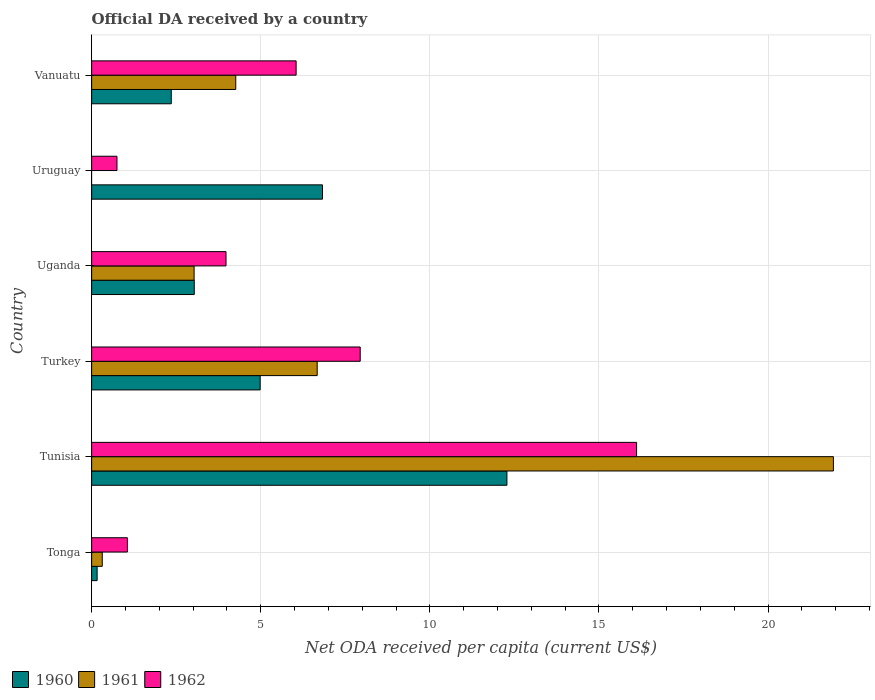How many groups of bars are there?
Offer a very short reply. 6. Are the number of bars per tick equal to the number of legend labels?
Your answer should be very brief. No. Are the number of bars on each tick of the Y-axis equal?
Provide a short and direct response. No. What is the label of the 3rd group of bars from the top?
Offer a terse response. Uganda. What is the ODA received in in 1961 in Uganda?
Offer a terse response. 3.03. Across all countries, what is the maximum ODA received in in 1960?
Offer a terse response. 12.28. Across all countries, what is the minimum ODA received in in 1962?
Provide a short and direct response. 0.75. In which country was the ODA received in in 1962 maximum?
Your answer should be compact. Tunisia. What is the total ODA received in in 1961 in the graph?
Your answer should be very brief. 36.21. What is the difference between the ODA received in in 1962 in Tunisia and that in Uruguay?
Your answer should be compact. 15.37. What is the difference between the ODA received in in 1962 in Tonga and the ODA received in in 1961 in Turkey?
Your answer should be compact. -5.61. What is the average ODA received in in 1961 per country?
Offer a very short reply. 6.03. What is the difference between the ODA received in in 1960 and ODA received in in 1961 in Tunisia?
Your answer should be compact. -9.65. In how many countries, is the ODA received in in 1960 greater than 7 US$?
Make the answer very short. 1. What is the ratio of the ODA received in in 1962 in Uganda to that in Uruguay?
Your answer should be compact. 5.31. What is the difference between the highest and the second highest ODA received in in 1961?
Provide a succinct answer. 15.26. What is the difference between the highest and the lowest ODA received in in 1962?
Provide a short and direct response. 15.37. In how many countries, is the ODA received in in 1960 greater than the average ODA received in in 1960 taken over all countries?
Ensure brevity in your answer.  3. Is the sum of the ODA received in in 1962 in Turkey and Vanuatu greater than the maximum ODA received in in 1960 across all countries?
Make the answer very short. Yes. Is it the case that in every country, the sum of the ODA received in in 1962 and ODA received in in 1960 is greater than the ODA received in in 1961?
Give a very brief answer. Yes. How many bars are there?
Ensure brevity in your answer.  17. Are all the bars in the graph horizontal?
Ensure brevity in your answer.  Yes. What is the difference between two consecutive major ticks on the X-axis?
Your response must be concise. 5. Are the values on the major ticks of X-axis written in scientific E-notation?
Provide a succinct answer. No. Does the graph contain any zero values?
Offer a terse response. Yes. What is the title of the graph?
Make the answer very short. Official DA received by a country. Does "1969" appear as one of the legend labels in the graph?
Keep it short and to the point. No. What is the label or title of the X-axis?
Make the answer very short. Net ODA received per capita (current US$). What is the Net ODA received per capita (current US$) in 1960 in Tonga?
Give a very brief answer. 0.16. What is the Net ODA received per capita (current US$) of 1961 in Tonga?
Offer a very short reply. 0.31. What is the Net ODA received per capita (current US$) of 1962 in Tonga?
Offer a very short reply. 1.06. What is the Net ODA received per capita (current US$) in 1960 in Tunisia?
Keep it short and to the point. 12.28. What is the Net ODA received per capita (current US$) in 1961 in Tunisia?
Give a very brief answer. 21.93. What is the Net ODA received per capita (current US$) in 1962 in Tunisia?
Offer a very short reply. 16.11. What is the Net ODA received per capita (current US$) of 1960 in Turkey?
Provide a short and direct response. 4.98. What is the Net ODA received per capita (current US$) in 1961 in Turkey?
Your response must be concise. 6.67. What is the Net ODA received per capita (current US$) in 1962 in Turkey?
Keep it short and to the point. 7.94. What is the Net ODA received per capita (current US$) of 1960 in Uganda?
Ensure brevity in your answer.  3.03. What is the Net ODA received per capita (current US$) of 1961 in Uganda?
Provide a succinct answer. 3.03. What is the Net ODA received per capita (current US$) of 1962 in Uganda?
Your answer should be compact. 3.97. What is the Net ODA received per capita (current US$) in 1960 in Uruguay?
Provide a succinct answer. 6.83. What is the Net ODA received per capita (current US$) of 1961 in Uruguay?
Give a very brief answer. 0. What is the Net ODA received per capita (current US$) in 1962 in Uruguay?
Make the answer very short. 0.75. What is the Net ODA received per capita (current US$) in 1960 in Vanuatu?
Offer a terse response. 2.35. What is the Net ODA received per capita (current US$) in 1961 in Vanuatu?
Provide a succinct answer. 4.26. What is the Net ODA received per capita (current US$) in 1962 in Vanuatu?
Your answer should be very brief. 6.05. Across all countries, what is the maximum Net ODA received per capita (current US$) in 1960?
Ensure brevity in your answer.  12.28. Across all countries, what is the maximum Net ODA received per capita (current US$) in 1961?
Offer a terse response. 21.93. Across all countries, what is the maximum Net ODA received per capita (current US$) of 1962?
Make the answer very short. 16.11. Across all countries, what is the minimum Net ODA received per capita (current US$) of 1960?
Your answer should be very brief. 0.16. Across all countries, what is the minimum Net ODA received per capita (current US$) of 1961?
Make the answer very short. 0. Across all countries, what is the minimum Net ODA received per capita (current US$) in 1962?
Your response must be concise. 0.75. What is the total Net ODA received per capita (current US$) in 1960 in the graph?
Make the answer very short. 29.64. What is the total Net ODA received per capita (current US$) in 1961 in the graph?
Your response must be concise. 36.21. What is the total Net ODA received per capita (current US$) in 1962 in the graph?
Give a very brief answer. 35.88. What is the difference between the Net ODA received per capita (current US$) of 1960 in Tonga and that in Tunisia?
Your answer should be compact. -12.12. What is the difference between the Net ODA received per capita (current US$) in 1961 in Tonga and that in Tunisia?
Your response must be concise. -21.62. What is the difference between the Net ODA received per capita (current US$) of 1962 in Tonga and that in Tunisia?
Your answer should be very brief. -15.06. What is the difference between the Net ODA received per capita (current US$) of 1960 in Tonga and that in Turkey?
Keep it short and to the point. -4.82. What is the difference between the Net ODA received per capita (current US$) of 1961 in Tonga and that in Turkey?
Make the answer very short. -6.36. What is the difference between the Net ODA received per capita (current US$) of 1962 in Tonga and that in Turkey?
Your answer should be very brief. -6.88. What is the difference between the Net ODA received per capita (current US$) of 1960 in Tonga and that in Uganda?
Offer a very short reply. -2.87. What is the difference between the Net ODA received per capita (current US$) of 1961 in Tonga and that in Uganda?
Ensure brevity in your answer.  -2.72. What is the difference between the Net ODA received per capita (current US$) in 1962 in Tonga and that in Uganda?
Your answer should be compact. -2.92. What is the difference between the Net ODA received per capita (current US$) of 1960 in Tonga and that in Uruguay?
Offer a terse response. -6.66. What is the difference between the Net ODA received per capita (current US$) of 1962 in Tonga and that in Uruguay?
Your answer should be very brief. 0.31. What is the difference between the Net ODA received per capita (current US$) of 1960 in Tonga and that in Vanuatu?
Your answer should be compact. -2.19. What is the difference between the Net ODA received per capita (current US$) in 1961 in Tonga and that in Vanuatu?
Make the answer very short. -3.95. What is the difference between the Net ODA received per capita (current US$) in 1962 in Tonga and that in Vanuatu?
Provide a short and direct response. -4.99. What is the difference between the Net ODA received per capita (current US$) of 1960 in Tunisia and that in Turkey?
Your response must be concise. 7.3. What is the difference between the Net ODA received per capita (current US$) in 1961 in Tunisia and that in Turkey?
Your answer should be compact. 15.26. What is the difference between the Net ODA received per capita (current US$) of 1962 in Tunisia and that in Turkey?
Provide a short and direct response. 8.17. What is the difference between the Net ODA received per capita (current US$) of 1960 in Tunisia and that in Uganda?
Your answer should be compact. 9.25. What is the difference between the Net ODA received per capita (current US$) of 1961 in Tunisia and that in Uganda?
Give a very brief answer. 18.9. What is the difference between the Net ODA received per capita (current US$) of 1962 in Tunisia and that in Uganda?
Give a very brief answer. 12.14. What is the difference between the Net ODA received per capita (current US$) of 1960 in Tunisia and that in Uruguay?
Offer a terse response. 5.45. What is the difference between the Net ODA received per capita (current US$) in 1962 in Tunisia and that in Uruguay?
Give a very brief answer. 15.37. What is the difference between the Net ODA received per capita (current US$) of 1960 in Tunisia and that in Vanuatu?
Provide a succinct answer. 9.93. What is the difference between the Net ODA received per capita (current US$) in 1961 in Tunisia and that in Vanuatu?
Keep it short and to the point. 17.67. What is the difference between the Net ODA received per capita (current US$) in 1962 in Tunisia and that in Vanuatu?
Your answer should be compact. 10.07. What is the difference between the Net ODA received per capita (current US$) of 1960 in Turkey and that in Uganda?
Keep it short and to the point. 1.95. What is the difference between the Net ODA received per capita (current US$) in 1961 in Turkey and that in Uganda?
Keep it short and to the point. 3.64. What is the difference between the Net ODA received per capita (current US$) in 1962 in Turkey and that in Uganda?
Your response must be concise. 3.97. What is the difference between the Net ODA received per capita (current US$) of 1960 in Turkey and that in Uruguay?
Keep it short and to the point. -1.84. What is the difference between the Net ODA received per capita (current US$) in 1962 in Turkey and that in Uruguay?
Offer a terse response. 7.19. What is the difference between the Net ODA received per capita (current US$) of 1960 in Turkey and that in Vanuatu?
Make the answer very short. 2.63. What is the difference between the Net ODA received per capita (current US$) in 1961 in Turkey and that in Vanuatu?
Ensure brevity in your answer.  2.41. What is the difference between the Net ODA received per capita (current US$) in 1962 in Turkey and that in Vanuatu?
Ensure brevity in your answer.  1.89. What is the difference between the Net ODA received per capita (current US$) in 1960 in Uganda and that in Uruguay?
Offer a terse response. -3.79. What is the difference between the Net ODA received per capita (current US$) in 1962 in Uganda and that in Uruguay?
Ensure brevity in your answer.  3.22. What is the difference between the Net ODA received per capita (current US$) of 1960 in Uganda and that in Vanuatu?
Give a very brief answer. 0.68. What is the difference between the Net ODA received per capita (current US$) of 1961 in Uganda and that in Vanuatu?
Your answer should be compact. -1.23. What is the difference between the Net ODA received per capita (current US$) of 1962 in Uganda and that in Vanuatu?
Provide a short and direct response. -2.07. What is the difference between the Net ODA received per capita (current US$) in 1960 in Uruguay and that in Vanuatu?
Keep it short and to the point. 4.47. What is the difference between the Net ODA received per capita (current US$) in 1962 in Uruguay and that in Vanuatu?
Your answer should be compact. -5.3. What is the difference between the Net ODA received per capita (current US$) in 1960 in Tonga and the Net ODA received per capita (current US$) in 1961 in Tunisia?
Offer a very short reply. -21.77. What is the difference between the Net ODA received per capita (current US$) of 1960 in Tonga and the Net ODA received per capita (current US$) of 1962 in Tunisia?
Keep it short and to the point. -15.95. What is the difference between the Net ODA received per capita (current US$) of 1961 in Tonga and the Net ODA received per capita (current US$) of 1962 in Tunisia?
Your answer should be very brief. -15.8. What is the difference between the Net ODA received per capita (current US$) in 1960 in Tonga and the Net ODA received per capita (current US$) in 1961 in Turkey?
Make the answer very short. -6.51. What is the difference between the Net ODA received per capita (current US$) of 1960 in Tonga and the Net ODA received per capita (current US$) of 1962 in Turkey?
Offer a very short reply. -7.78. What is the difference between the Net ODA received per capita (current US$) in 1961 in Tonga and the Net ODA received per capita (current US$) in 1962 in Turkey?
Provide a short and direct response. -7.63. What is the difference between the Net ODA received per capita (current US$) in 1960 in Tonga and the Net ODA received per capita (current US$) in 1961 in Uganda?
Make the answer very short. -2.87. What is the difference between the Net ODA received per capita (current US$) in 1960 in Tonga and the Net ODA received per capita (current US$) in 1962 in Uganda?
Your response must be concise. -3.81. What is the difference between the Net ODA received per capita (current US$) of 1961 in Tonga and the Net ODA received per capita (current US$) of 1962 in Uganda?
Keep it short and to the point. -3.66. What is the difference between the Net ODA received per capita (current US$) of 1960 in Tonga and the Net ODA received per capita (current US$) of 1962 in Uruguay?
Keep it short and to the point. -0.59. What is the difference between the Net ODA received per capita (current US$) of 1961 in Tonga and the Net ODA received per capita (current US$) of 1962 in Uruguay?
Make the answer very short. -0.44. What is the difference between the Net ODA received per capita (current US$) in 1960 in Tonga and the Net ODA received per capita (current US$) in 1961 in Vanuatu?
Your response must be concise. -4.1. What is the difference between the Net ODA received per capita (current US$) of 1960 in Tonga and the Net ODA received per capita (current US$) of 1962 in Vanuatu?
Offer a very short reply. -5.88. What is the difference between the Net ODA received per capita (current US$) of 1961 in Tonga and the Net ODA received per capita (current US$) of 1962 in Vanuatu?
Your answer should be very brief. -5.73. What is the difference between the Net ODA received per capita (current US$) in 1960 in Tunisia and the Net ODA received per capita (current US$) in 1961 in Turkey?
Give a very brief answer. 5.61. What is the difference between the Net ODA received per capita (current US$) of 1960 in Tunisia and the Net ODA received per capita (current US$) of 1962 in Turkey?
Give a very brief answer. 4.34. What is the difference between the Net ODA received per capita (current US$) in 1961 in Tunisia and the Net ODA received per capita (current US$) in 1962 in Turkey?
Make the answer very short. 13.99. What is the difference between the Net ODA received per capita (current US$) of 1960 in Tunisia and the Net ODA received per capita (current US$) of 1961 in Uganda?
Ensure brevity in your answer.  9.25. What is the difference between the Net ODA received per capita (current US$) of 1960 in Tunisia and the Net ODA received per capita (current US$) of 1962 in Uganda?
Ensure brevity in your answer.  8.31. What is the difference between the Net ODA received per capita (current US$) of 1961 in Tunisia and the Net ODA received per capita (current US$) of 1962 in Uganda?
Give a very brief answer. 17.96. What is the difference between the Net ODA received per capita (current US$) in 1960 in Tunisia and the Net ODA received per capita (current US$) in 1962 in Uruguay?
Give a very brief answer. 11.53. What is the difference between the Net ODA received per capita (current US$) in 1961 in Tunisia and the Net ODA received per capita (current US$) in 1962 in Uruguay?
Provide a short and direct response. 21.19. What is the difference between the Net ODA received per capita (current US$) in 1960 in Tunisia and the Net ODA received per capita (current US$) in 1961 in Vanuatu?
Offer a terse response. 8.02. What is the difference between the Net ODA received per capita (current US$) in 1960 in Tunisia and the Net ODA received per capita (current US$) in 1962 in Vanuatu?
Offer a very short reply. 6.23. What is the difference between the Net ODA received per capita (current US$) of 1961 in Tunisia and the Net ODA received per capita (current US$) of 1962 in Vanuatu?
Keep it short and to the point. 15.89. What is the difference between the Net ODA received per capita (current US$) in 1960 in Turkey and the Net ODA received per capita (current US$) in 1961 in Uganda?
Provide a short and direct response. 1.95. What is the difference between the Net ODA received per capita (current US$) in 1960 in Turkey and the Net ODA received per capita (current US$) in 1962 in Uganda?
Your answer should be very brief. 1.01. What is the difference between the Net ODA received per capita (current US$) in 1961 in Turkey and the Net ODA received per capita (current US$) in 1962 in Uganda?
Give a very brief answer. 2.7. What is the difference between the Net ODA received per capita (current US$) of 1960 in Turkey and the Net ODA received per capita (current US$) of 1962 in Uruguay?
Keep it short and to the point. 4.23. What is the difference between the Net ODA received per capita (current US$) of 1961 in Turkey and the Net ODA received per capita (current US$) of 1962 in Uruguay?
Offer a very short reply. 5.92. What is the difference between the Net ODA received per capita (current US$) of 1960 in Turkey and the Net ODA received per capita (current US$) of 1961 in Vanuatu?
Offer a very short reply. 0.72. What is the difference between the Net ODA received per capita (current US$) of 1960 in Turkey and the Net ODA received per capita (current US$) of 1962 in Vanuatu?
Your answer should be very brief. -1.06. What is the difference between the Net ODA received per capita (current US$) of 1961 in Turkey and the Net ODA received per capita (current US$) of 1962 in Vanuatu?
Ensure brevity in your answer.  0.62. What is the difference between the Net ODA received per capita (current US$) of 1960 in Uganda and the Net ODA received per capita (current US$) of 1962 in Uruguay?
Provide a short and direct response. 2.29. What is the difference between the Net ODA received per capita (current US$) of 1961 in Uganda and the Net ODA received per capita (current US$) of 1962 in Uruguay?
Give a very brief answer. 2.28. What is the difference between the Net ODA received per capita (current US$) of 1960 in Uganda and the Net ODA received per capita (current US$) of 1961 in Vanuatu?
Keep it short and to the point. -1.23. What is the difference between the Net ODA received per capita (current US$) in 1960 in Uganda and the Net ODA received per capita (current US$) in 1962 in Vanuatu?
Offer a very short reply. -3.01. What is the difference between the Net ODA received per capita (current US$) of 1961 in Uganda and the Net ODA received per capita (current US$) of 1962 in Vanuatu?
Make the answer very short. -3.02. What is the difference between the Net ODA received per capita (current US$) of 1960 in Uruguay and the Net ODA received per capita (current US$) of 1961 in Vanuatu?
Ensure brevity in your answer.  2.57. What is the difference between the Net ODA received per capita (current US$) of 1960 in Uruguay and the Net ODA received per capita (current US$) of 1962 in Vanuatu?
Your answer should be very brief. 0.78. What is the average Net ODA received per capita (current US$) in 1960 per country?
Offer a terse response. 4.94. What is the average Net ODA received per capita (current US$) of 1961 per country?
Offer a very short reply. 6.03. What is the average Net ODA received per capita (current US$) of 1962 per country?
Provide a succinct answer. 5.98. What is the difference between the Net ODA received per capita (current US$) in 1960 and Net ODA received per capita (current US$) in 1961 in Tonga?
Give a very brief answer. -0.15. What is the difference between the Net ODA received per capita (current US$) of 1960 and Net ODA received per capita (current US$) of 1962 in Tonga?
Ensure brevity in your answer.  -0.89. What is the difference between the Net ODA received per capita (current US$) of 1961 and Net ODA received per capita (current US$) of 1962 in Tonga?
Ensure brevity in your answer.  -0.74. What is the difference between the Net ODA received per capita (current US$) of 1960 and Net ODA received per capita (current US$) of 1961 in Tunisia?
Ensure brevity in your answer.  -9.65. What is the difference between the Net ODA received per capita (current US$) of 1960 and Net ODA received per capita (current US$) of 1962 in Tunisia?
Your answer should be compact. -3.83. What is the difference between the Net ODA received per capita (current US$) in 1961 and Net ODA received per capita (current US$) in 1962 in Tunisia?
Make the answer very short. 5.82. What is the difference between the Net ODA received per capita (current US$) in 1960 and Net ODA received per capita (current US$) in 1961 in Turkey?
Your answer should be very brief. -1.69. What is the difference between the Net ODA received per capita (current US$) of 1960 and Net ODA received per capita (current US$) of 1962 in Turkey?
Offer a very short reply. -2.96. What is the difference between the Net ODA received per capita (current US$) of 1961 and Net ODA received per capita (current US$) of 1962 in Turkey?
Give a very brief answer. -1.27. What is the difference between the Net ODA received per capita (current US$) in 1960 and Net ODA received per capita (current US$) in 1961 in Uganda?
Offer a very short reply. 0. What is the difference between the Net ODA received per capita (current US$) in 1960 and Net ODA received per capita (current US$) in 1962 in Uganda?
Ensure brevity in your answer.  -0.94. What is the difference between the Net ODA received per capita (current US$) in 1961 and Net ODA received per capita (current US$) in 1962 in Uganda?
Keep it short and to the point. -0.94. What is the difference between the Net ODA received per capita (current US$) in 1960 and Net ODA received per capita (current US$) in 1962 in Uruguay?
Your answer should be very brief. 6.08. What is the difference between the Net ODA received per capita (current US$) in 1960 and Net ODA received per capita (current US$) in 1961 in Vanuatu?
Provide a short and direct response. -1.91. What is the difference between the Net ODA received per capita (current US$) of 1960 and Net ODA received per capita (current US$) of 1962 in Vanuatu?
Give a very brief answer. -3.69. What is the difference between the Net ODA received per capita (current US$) of 1961 and Net ODA received per capita (current US$) of 1962 in Vanuatu?
Keep it short and to the point. -1.79. What is the ratio of the Net ODA received per capita (current US$) of 1960 in Tonga to that in Tunisia?
Offer a very short reply. 0.01. What is the ratio of the Net ODA received per capita (current US$) of 1961 in Tonga to that in Tunisia?
Keep it short and to the point. 0.01. What is the ratio of the Net ODA received per capita (current US$) in 1962 in Tonga to that in Tunisia?
Provide a succinct answer. 0.07. What is the ratio of the Net ODA received per capita (current US$) in 1960 in Tonga to that in Turkey?
Your answer should be compact. 0.03. What is the ratio of the Net ODA received per capita (current US$) of 1961 in Tonga to that in Turkey?
Offer a very short reply. 0.05. What is the ratio of the Net ODA received per capita (current US$) in 1962 in Tonga to that in Turkey?
Offer a very short reply. 0.13. What is the ratio of the Net ODA received per capita (current US$) in 1960 in Tonga to that in Uganda?
Your response must be concise. 0.05. What is the ratio of the Net ODA received per capita (current US$) of 1961 in Tonga to that in Uganda?
Give a very brief answer. 0.1. What is the ratio of the Net ODA received per capita (current US$) in 1962 in Tonga to that in Uganda?
Your response must be concise. 0.27. What is the ratio of the Net ODA received per capita (current US$) in 1960 in Tonga to that in Uruguay?
Give a very brief answer. 0.02. What is the ratio of the Net ODA received per capita (current US$) of 1962 in Tonga to that in Uruguay?
Provide a short and direct response. 1.41. What is the ratio of the Net ODA received per capita (current US$) in 1960 in Tonga to that in Vanuatu?
Your response must be concise. 0.07. What is the ratio of the Net ODA received per capita (current US$) of 1961 in Tonga to that in Vanuatu?
Your response must be concise. 0.07. What is the ratio of the Net ODA received per capita (current US$) in 1962 in Tonga to that in Vanuatu?
Your answer should be compact. 0.17. What is the ratio of the Net ODA received per capita (current US$) in 1960 in Tunisia to that in Turkey?
Your answer should be very brief. 2.46. What is the ratio of the Net ODA received per capita (current US$) in 1961 in Tunisia to that in Turkey?
Your answer should be very brief. 3.29. What is the ratio of the Net ODA received per capita (current US$) of 1962 in Tunisia to that in Turkey?
Ensure brevity in your answer.  2.03. What is the ratio of the Net ODA received per capita (current US$) of 1960 in Tunisia to that in Uganda?
Give a very brief answer. 4.05. What is the ratio of the Net ODA received per capita (current US$) of 1961 in Tunisia to that in Uganda?
Your answer should be compact. 7.24. What is the ratio of the Net ODA received per capita (current US$) of 1962 in Tunisia to that in Uganda?
Provide a short and direct response. 4.06. What is the ratio of the Net ODA received per capita (current US$) in 1960 in Tunisia to that in Uruguay?
Ensure brevity in your answer.  1.8. What is the ratio of the Net ODA received per capita (current US$) in 1962 in Tunisia to that in Uruguay?
Offer a terse response. 21.52. What is the ratio of the Net ODA received per capita (current US$) in 1960 in Tunisia to that in Vanuatu?
Make the answer very short. 5.21. What is the ratio of the Net ODA received per capita (current US$) in 1961 in Tunisia to that in Vanuatu?
Your answer should be very brief. 5.15. What is the ratio of the Net ODA received per capita (current US$) in 1962 in Tunisia to that in Vanuatu?
Offer a very short reply. 2.67. What is the ratio of the Net ODA received per capita (current US$) in 1960 in Turkey to that in Uganda?
Your answer should be very brief. 1.64. What is the ratio of the Net ODA received per capita (current US$) of 1961 in Turkey to that in Uganda?
Your answer should be very brief. 2.2. What is the ratio of the Net ODA received per capita (current US$) of 1962 in Turkey to that in Uganda?
Give a very brief answer. 2. What is the ratio of the Net ODA received per capita (current US$) of 1960 in Turkey to that in Uruguay?
Your response must be concise. 0.73. What is the ratio of the Net ODA received per capita (current US$) in 1962 in Turkey to that in Uruguay?
Your answer should be compact. 10.6. What is the ratio of the Net ODA received per capita (current US$) of 1960 in Turkey to that in Vanuatu?
Provide a short and direct response. 2.12. What is the ratio of the Net ODA received per capita (current US$) of 1961 in Turkey to that in Vanuatu?
Provide a succinct answer. 1.57. What is the ratio of the Net ODA received per capita (current US$) in 1962 in Turkey to that in Vanuatu?
Provide a short and direct response. 1.31. What is the ratio of the Net ODA received per capita (current US$) of 1960 in Uganda to that in Uruguay?
Offer a terse response. 0.44. What is the ratio of the Net ODA received per capita (current US$) in 1962 in Uganda to that in Uruguay?
Make the answer very short. 5.31. What is the ratio of the Net ODA received per capita (current US$) of 1960 in Uganda to that in Vanuatu?
Provide a succinct answer. 1.29. What is the ratio of the Net ODA received per capita (current US$) in 1961 in Uganda to that in Vanuatu?
Make the answer very short. 0.71. What is the ratio of the Net ODA received per capita (current US$) of 1962 in Uganda to that in Vanuatu?
Offer a terse response. 0.66. What is the ratio of the Net ODA received per capita (current US$) in 1960 in Uruguay to that in Vanuatu?
Give a very brief answer. 2.9. What is the ratio of the Net ODA received per capita (current US$) of 1962 in Uruguay to that in Vanuatu?
Give a very brief answer. 0.12. What is the difference between the highest and the second highest Net ODA received per capita (current US$) of 1960?
Offer a terse response. 5.45. What is the difference between the highest and the second highest Net ODA received per capita (current US$) in 1961?
Offer a terse response. 15.26. What is the difference between the highest and the second highest Net ODA received per capita (current US$) of 1962?
Keep it short and to the point. 8.17. What is the difference between the highest and the lowest Net ODA received per capita (current US$) in 1960?
Offer a terse response. 12.12. What is the difference between the highest and the lowest Net ODA received per capita (current US$) of 1961?
Provide a short and direct response. 21.93. What is the difference between the highest and the lowest Net ODA received per capita (current US$) of 1962?
Provide a short and direct response. 15.37. 